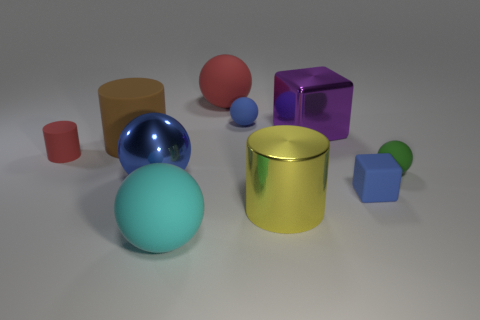Subtract 1 cylinders. How many cylinders are left? 2 Subtract all red balls. How many balls are left? 4 Subtract all matte cylinders. How many cylinders are left? 1 Subtract all cylinders. How many objects are left? 7 Subtract all green balls. Subtract all yellow cylinders. How many balls are left? 4 Subtract all cyan rubber balls. Subtract all large cyan things. How many objects are left? 8 Add 6 big matte balls. How many big matte balls are left? 8 Add 8 blue rubber balls. How many blue rubber balls exist? 9 Subtract 1 yellow cylinders. How many objects are left? 9 